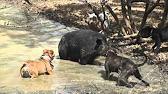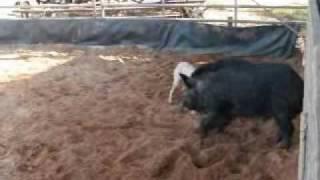The first image is the image on the left, the second image is the image on the right. Considering the images on both sides, is "There are at least four black boars outside." valid? Answer yes or no. No. The first image is the image on the left, the second image is the image on the right. Assess this claim about the two images: "In at least one of the images, one dog is facing off with one hog.". Correct or not? Answer yes or no. No. 